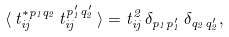<formula> <loc_0><loc_0><loc_500><loc_500>\langle \, t ^ { * p _ { 1 } q _ { 2 } } _ { i j } \, t ^ { p _ { 1 } ^ { \prime } q _ { 2 } ^ { \prime } } _ { i j } \, \rangle = t ^ { 2 } _ { i j } \, \delta _ { p _ { 1 } p _ { 1 } ^ { \prime } } \, \delta _ { q _ { 2 } q _ { 2 } ^ { \prime } } ,</formula> 